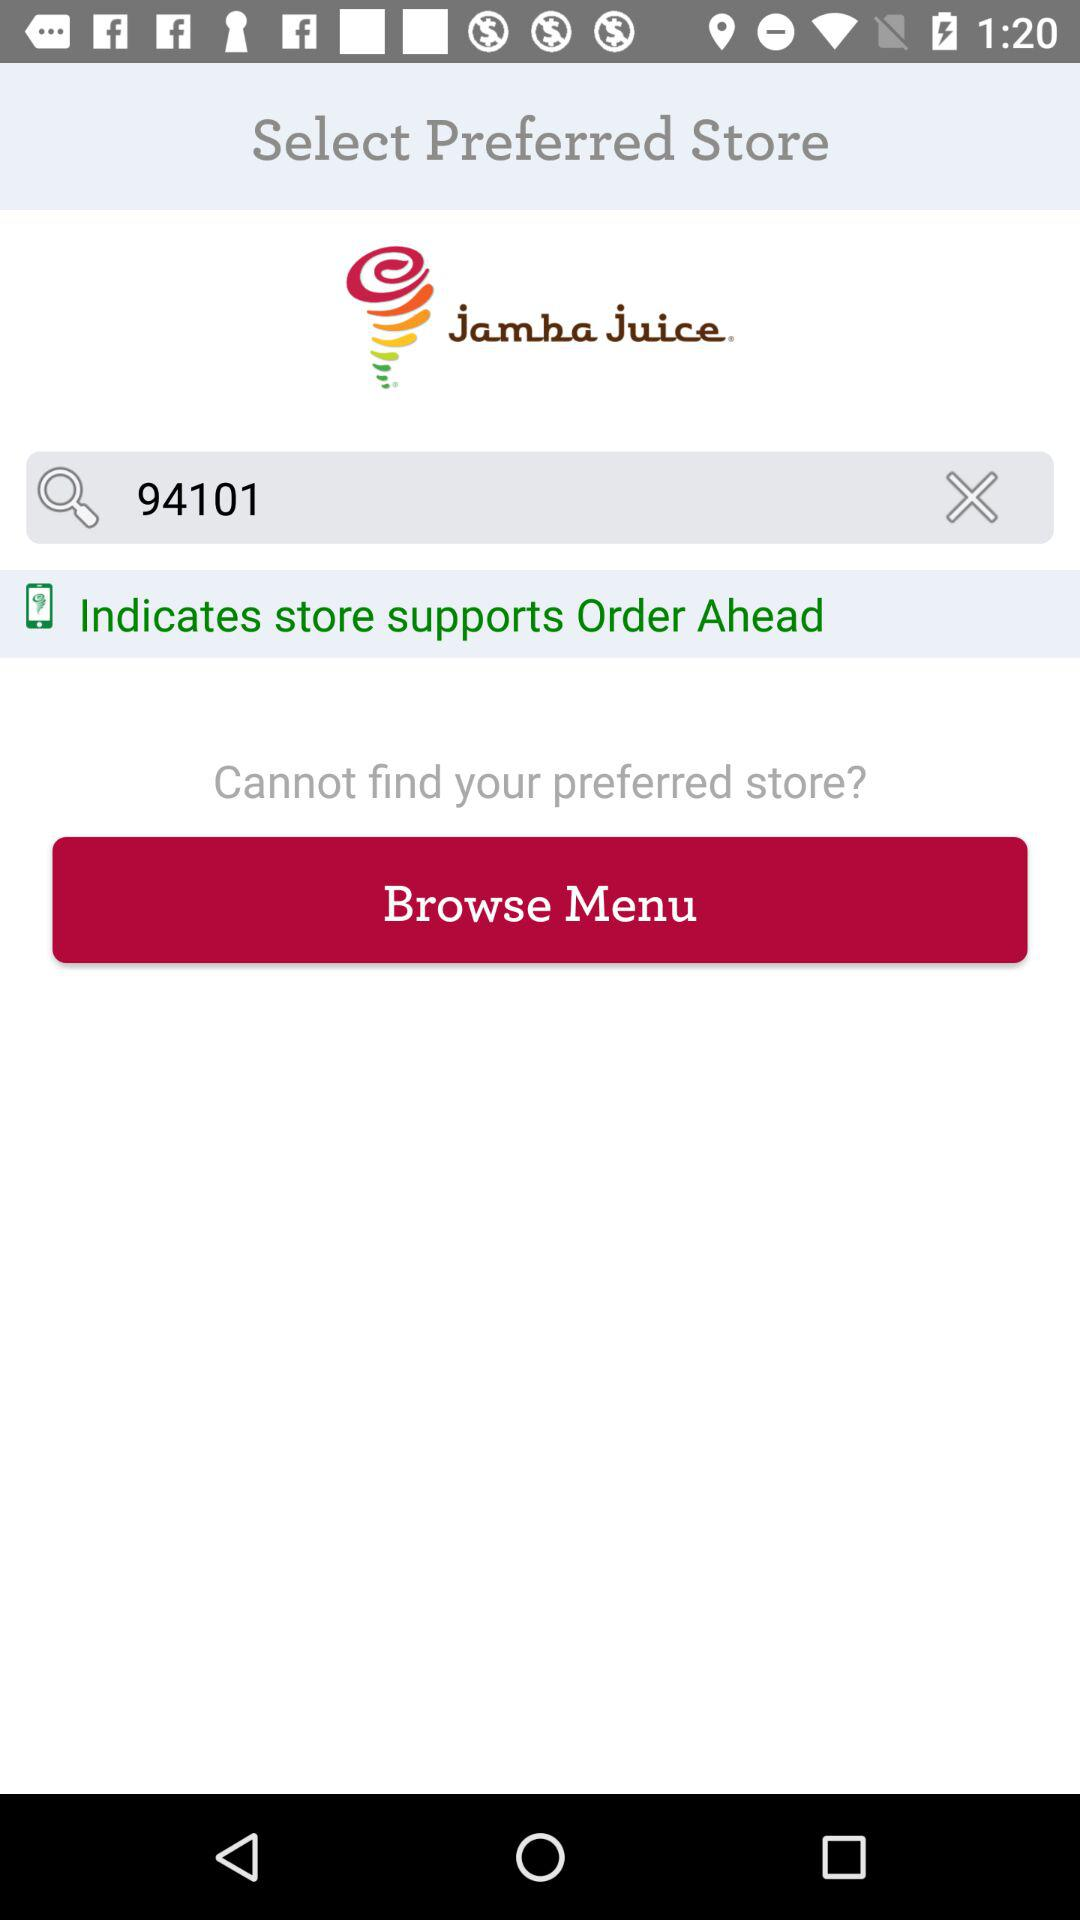What is the given store name? The store name is "jamba juice". 